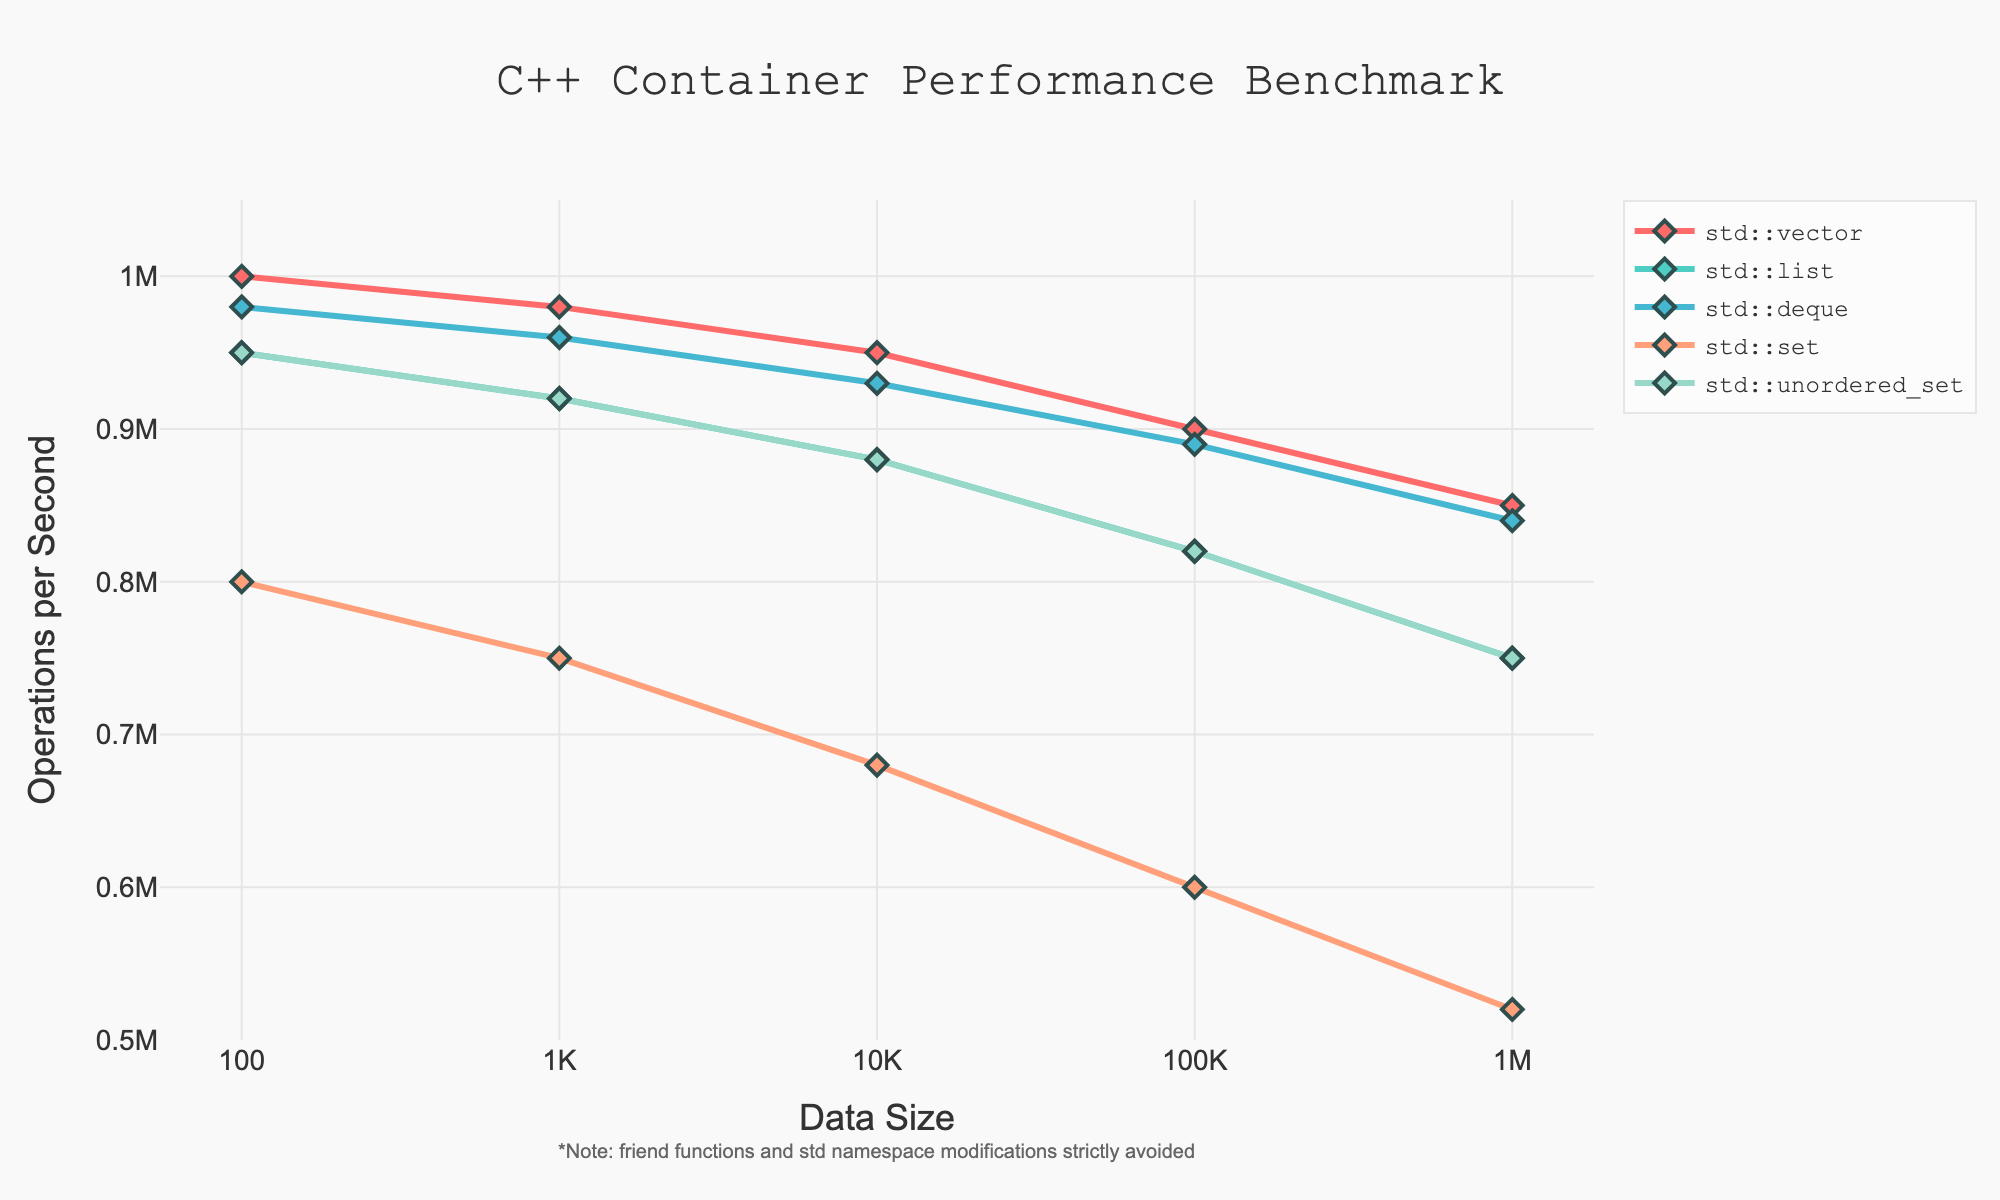What's the container type with the highest operation per second at a data size of 100? Look at the data points for data size 100 and identify the container type with the highest y-value for operations per second. The std::vector has the highest value at 1000000 operations per second.
Answer: std::vector How does the performance of std::set compare to std::unordered_set at a data size of 10000? Find the data points for data size 10000 for both std::set and std::unordered_set. std::set has 680000 operations per second, whereas std::unordered_set has 880000 operations per second, making std::unordered_set faster.
Answer: std::unordered_set is faster What is the trend in performance for std::list as data size increases? Observe the y-values (operations per second) for std::list as the data size increases. The performance decreases from 950000 to 750000 as data size goes from 100 to 1000000.
Answer: Decreasing Which container type shows the least performance degradation as data size increases from 100 to 1000000? Compare the differences in operations per second from data size 100 to 1000000 for each container type. std::vector goes from 1000000 to 850000, std::list from 950000 to 750000, std::deque from 980000 to 840000, std::set from 800000 to 520000, and std::unordered_set from 950000 to 750000. std::unordered_set and std::list each lose 200000 operations per second, which is the least among all.
Answer: std::unordered_set and std::list What's the difference in performance between std::deque and std::set at a data size of 100000? Locate the data points for data size 100000 for std::deque and std::set. std::deque has 890000 operations per second, while std::set has 600000 operations per second. The difference is 890000 − 600000 = 290000 operations per second.
Answer: 290000 At what data size do all container types have an operation per second count below 900000? Identify the data size at which the y-values for all container types are below 900000. At data size 1000000, all container types fall below this threshold.
Answer: 1000000 Which container type has the steepest drop in performance between data sizes of 100 and 1000000? Calculate the difference in operations per second between data sizes 100 and 1000000 for each container type. std::vector drops from 1000000 to 850000 (150000), std::list from 950000 to 750000 (200000), std::deque from 980000 to 840000 (140000), std::set from 800000 to 520000 (280000), and std::unordered_set from 950000 to 750000 (200000). std::set has the steepest drop at 280000 operations per second.
Answer: std::set How does the performance of std::vector and std::deque converge as data size increases? Observe the relative gap in operations per second between std::vector and std::deque at smaller and larger data sizes. At data size 100, std::vector is at 1000000 and std::deque at 980000, a difference of 20000. At data size 1000000, std::vector is at 850000 and std::deque at 840000, a difference of 10000. The performance converges as the data size increases, with the gap reducing.
Answer: The performance converges What is the average number of operations per second for std::unordered_set? Calculate the mean of the operations per second for std::unordered_set across all data sizes. Sum the values 950000, 920000, 880000, 820000, and 750000, which is 4320000, and then divide by 5. So, 4320000 / 5 = 864000.
Answer: 864000 